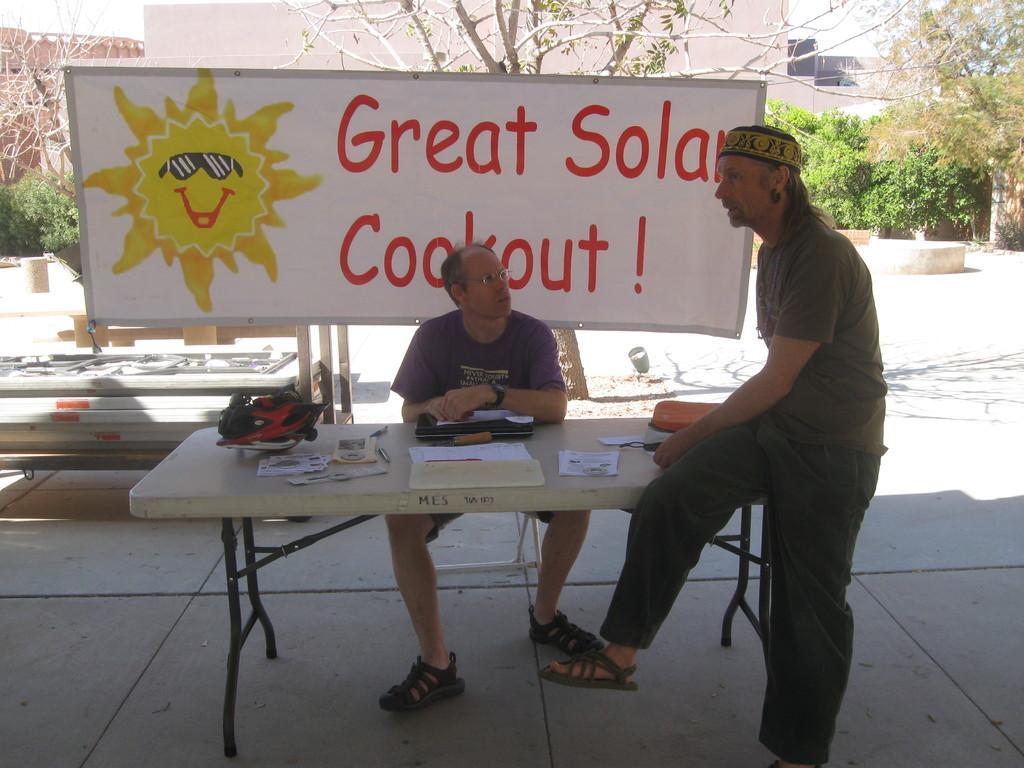Please provide a concise description of this image. In the center of the image there is a table on which there are objects. There is a person sitting on a chair. On the right side of the image there is a person leaning on the table. In the background of the image there is a banner. There are plants, house, trees. At the bottom of the image there is floor. 